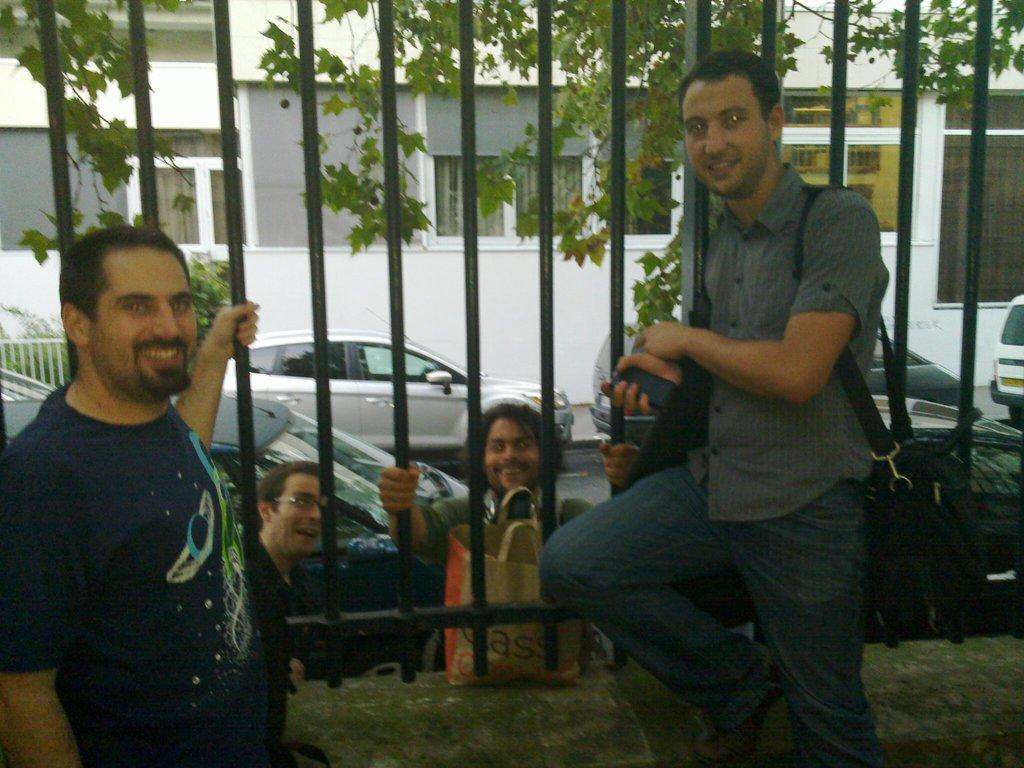How many people are in front of the grills in the image? There are two people in front of the grills in the image. What are the people on the other side of the grills doing? The people on the other side of the grills have bags, which suggests they might be preparing to leave or have just arrived. What can be seen in the image besides the grills and people? Vehicles, trees, and buildings are visible in the image. What theory is being discussed by the people in front of the grills in the image? There is no indication in the image that the people are discussing a theory. How many rails can be seen in the image? There are no rails present in the image. 